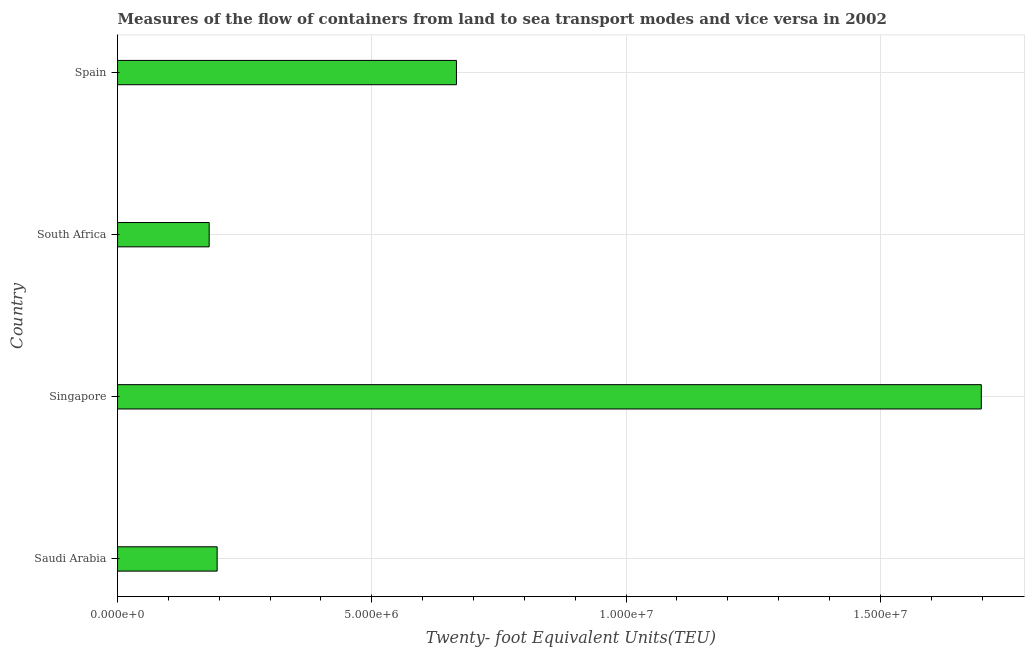Does the graph contain any zero values?
Provide a short and direct response. No. What is the title of the graph?
Your answer should be very brief. Measures of the flow of containers from land to sea transport modes and vice versa in 2002. What is the label or title of the X-axis?
Your answer should be very brief. Twenty- foot Equivalent Units(TEU). What is the label or title of the Y-axis?
Provide a short and direct response. Country. What is the container port traffic in South Africa?
Make the answer very short. 1.80e+06. Across all countries, what is the maximum container port traffic?
Make the answer very short. 1.70e+07. Across all countries, what is the minimum container port traffic?
Your answer should be very brief. 1.80e+06. In which country was the container port traffic maximum?
Ensure brevity in your answer.  Singapore. In which country was the container port traffic minimum?
Your answer should be compact. South Africa. What is the sum of the container port traffic?
Your response must be concise. 2.74e+07. What is the difference between the container port traffic in Singapore and South Africa?
Ensure brevity in your answer.  1.52e+07. What is the average container port traffic per country?
Provide a short and direct response. 6.85e+06. What is the median container port traffic?
Offer a very short reply. 4.31e+06. What is the ratio of the container port traffic in Saudi Arabia to that in Singapore?
Give a very brief answer. 0.12. Is the difference between the container port traffic in South Africa and Spain greater than the difference between any two countries?
Offer a very short reply. No. What is the difference between the highest and the second highest container port traffic?
Offer a terse response. 1.03e+07. What is the difference between the highest and the lowest container port traffic?
Provide a succinct answer. 1.52e+07. How many bars are there?
Your answer should be very brief. 4. How many countries are there in the graph?
Provide a short and direct response. 4. What is the difference between two consecutive major ticks on the X-axis?
Your response must be concise. 5.00e+06. What is the Twenty- foot Equivalent Units(TEU) in Saudi Arabia?
Keep it short and to the point. 1.96e+06. What is the Twenty- foot Equivalent Units(TEU) of Singapore?
Make the answer very short. 1.70e+07. What is the Twenty- foot Equivalent Units(TEU) in South Africa?
Your answer should be compact. 1.80e+06. What is the Twenty- foot Equivalent Units(TEU) in Spain?
Offer a very short reply. 6.66e+06. What is the difference between the Twenty- foot Equivalent Units(TEU) in Saudi Arabia and Singapore?
Offer a very short reply. -1.50e+07. What is the difference between the Twenty- foot Equivalent Units(TEU) in Saudi Arabia and South Africa?
Provide a short and direct response. 1.57e+05. What is the difference between the Twenty- foot Equivalent Units(TEU) in Saudi Arabia and Spain?
Offer a terse response. -4.71e+06. What is the difference between the Twenty- foot Equivalent Units(TEU) in Singapore and South Africa?
Give a very brief answer. 1.52e+07. What is the difference between the Twenty- foot Equivalent Units(TEU) in Singapore and Spain?
Your answer should be compact. 1.03e+07. What is the difference between the Twenty- foot Equivalent Units(TEU) in South Africa and Spain?
Your response must be concise. -4.86e+06. What is the ratio of the Twenty- foot Equivalent Units(TEU) in Saudi Arabia to that in Singapore?
Keep it short and to the point. 0.12. What is the ratio of the Twenty- foot Equivalent Units(TEU) in Saudi Arabia to that in South Africa?
Provide a short and direct response. 1.09. What is the ratio of the Twenty- foot Equivalent Units(TEU) in Saudi Arabia to that in Spain?
Offer a terse response. 0.29. What is the ratio of the Twenty- foot Equivalent Units(TEU) in Singapore to that in South Africa?
Ensure brevity in your answer.  9.43. What is the ratio of the Twenty- foot Equivalent Units(TEU) in Singapore to that in Spain?
Make the answer very short. 2.55. What is the ratio of the Twenty- foot Equivalent Units(TEU) in South Africa to that in Spain?
Your response must be concise. 0.27. 